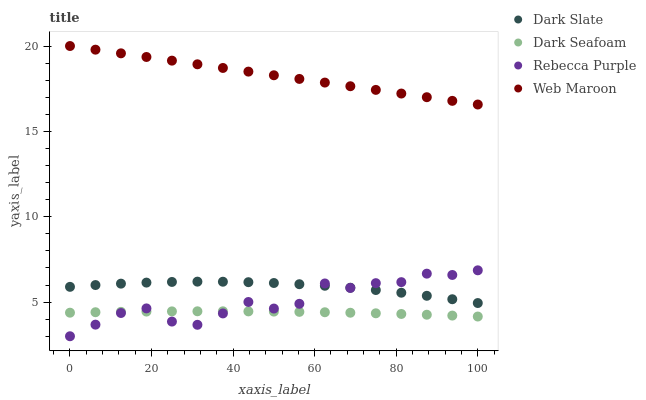Does Dark Seafoam have the minimum area under the curve?
Answer yes or no. Yes. Does Web Maroon have the maximum area under the curve?
Answer yes or no. Yes. Does Web Maroon have the minimum area under the curve?
Answer yes or no. No. Does Dark Seafoam have the maximum area under the curve?
Answer yes or no. No. Is Web Maroon the smoothest?
Answer yes or no. Yes. Is Rebecca Purple the roughest?
Answer yes or no. Yes. Is Dark Seafoam the smoothest?
Answer yes or no. No. Is Dark Seafoam the roughest?
Answer yes or no. No. Does Rebecca Purple have the lowest value?
Answer yes or no. Yes. Does Dark Seafoam have the lowest value?
Answer yes or no. No. Does Web Maroon have the highest value?
Answer yes or no. Yes. Does Dark Seafoam have the highest value?
Answer yes or no. No. Is Rebecca Purple less than Web Maroon?
Answer yes or no. Yes. Is Web Maroon greater than Dark Seafoam?
Answer yes or no. Yes. Does Rebecca Purple intersect Dark Seafoam?
Answer yes or no. Yes. Is Rebecca Purple less than Dark Seafoam?
Answer yes or no. No. Is Rebecca Purple greater than Dark Seafoam?
Answer yes or no. No. Does Rebecca Purple intersect Web Maroon?
Answer yes or no. No. 